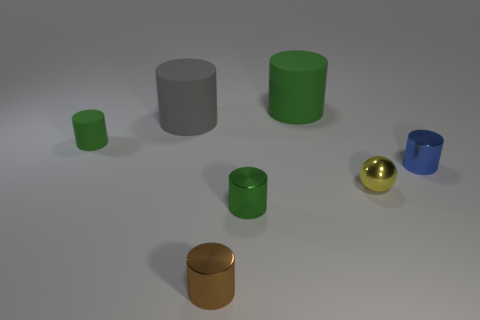How many green cylinders must be subtracted to get 1 green cylinders? 2 Subtract all large rubber cylinders. How many cylinders are left? 4 Add 1 big rubber objects. How many objects exist? 8 Subtract all brown cylinders. How many cylinders are left? 5 Subtract all green spheres. How many green cylinders are left? 3 Subtract 1 cylinders. How many cylinders are left? 5 Subtract all balls. How many objects are left? 6 Subtract all gray balls. Subtract all gray blocks. How many balls are left? 1 Subtract all small blue rubber blocks. Subtract all tiny cylinders. How many objects are left? 3 Add 3 small matte cylinders. How many small matte cylinders are left? 4 